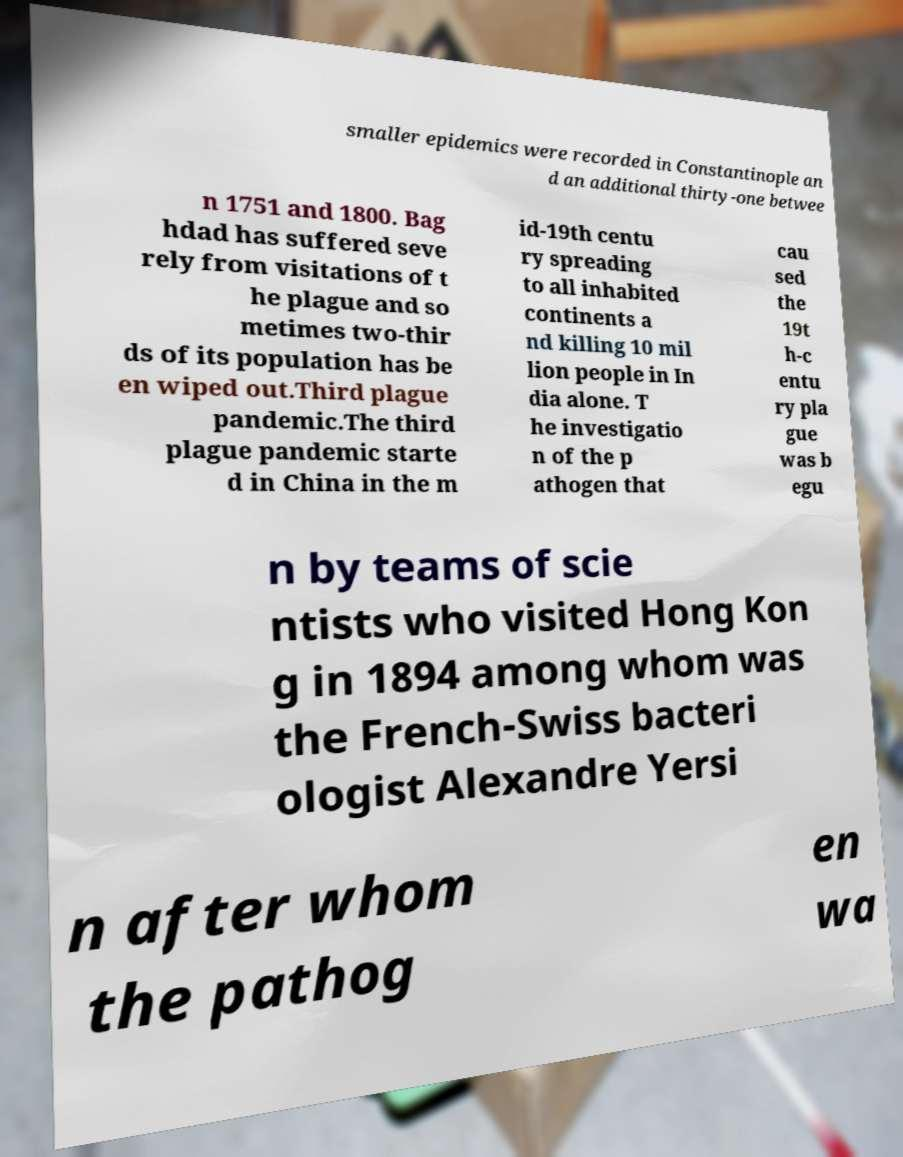Could you assist in decoding the text presented in this image and type it out clearly? smaller epidemics were recorded in Constantinople an d an additional thirty-one betwee n 1751 and 1800. Bag hdad has suffered seve rely from visitations of t he plague and so metimes two-thir ds of its population has be en wiped out.Third plague pandemic.The third plague pandemic starte d in China in the m id-19th centu ry spreading to all inhabited continents a nd killing 10 mil lion people in In dia alone. T he investigatio n of the p athogen that cau sed the 19t h-c entu ry pla gue was b egu n by teams of scie ntists who visited Hong Kon g in 1894 among whom was the French-Swiss bacteri ologist Alexandre Yersi n after whom the pathog en wa 